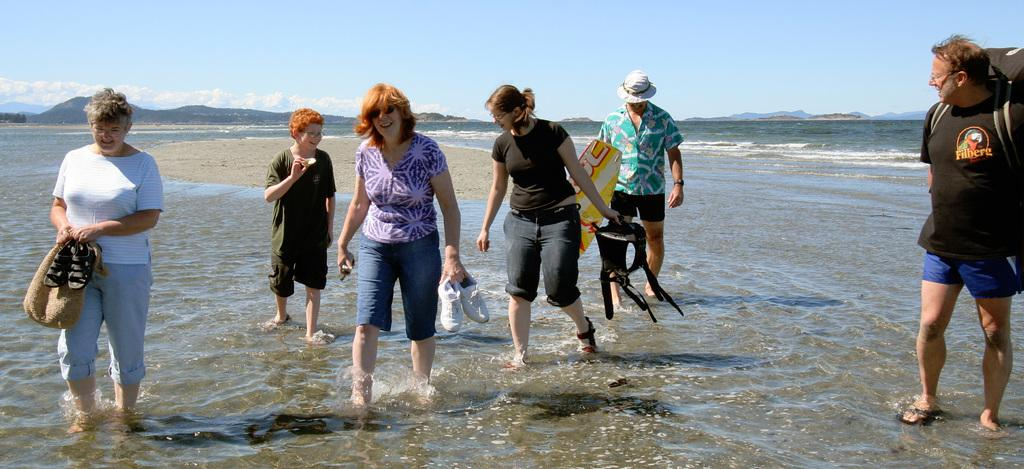What are the people in the image doing? The people in the image are standing in the water. What are the people holding in the image? The people are holding objects. What can be seen in the background of the image? There are mountains and the sky visible in the background of the image. What yard game are the people playing in the image? There is no yard game present in the image; the people are standing in the water. What fact can be learned about the people in the image? There is no specific fact about the people in the image that can be learned from the provided facts. 